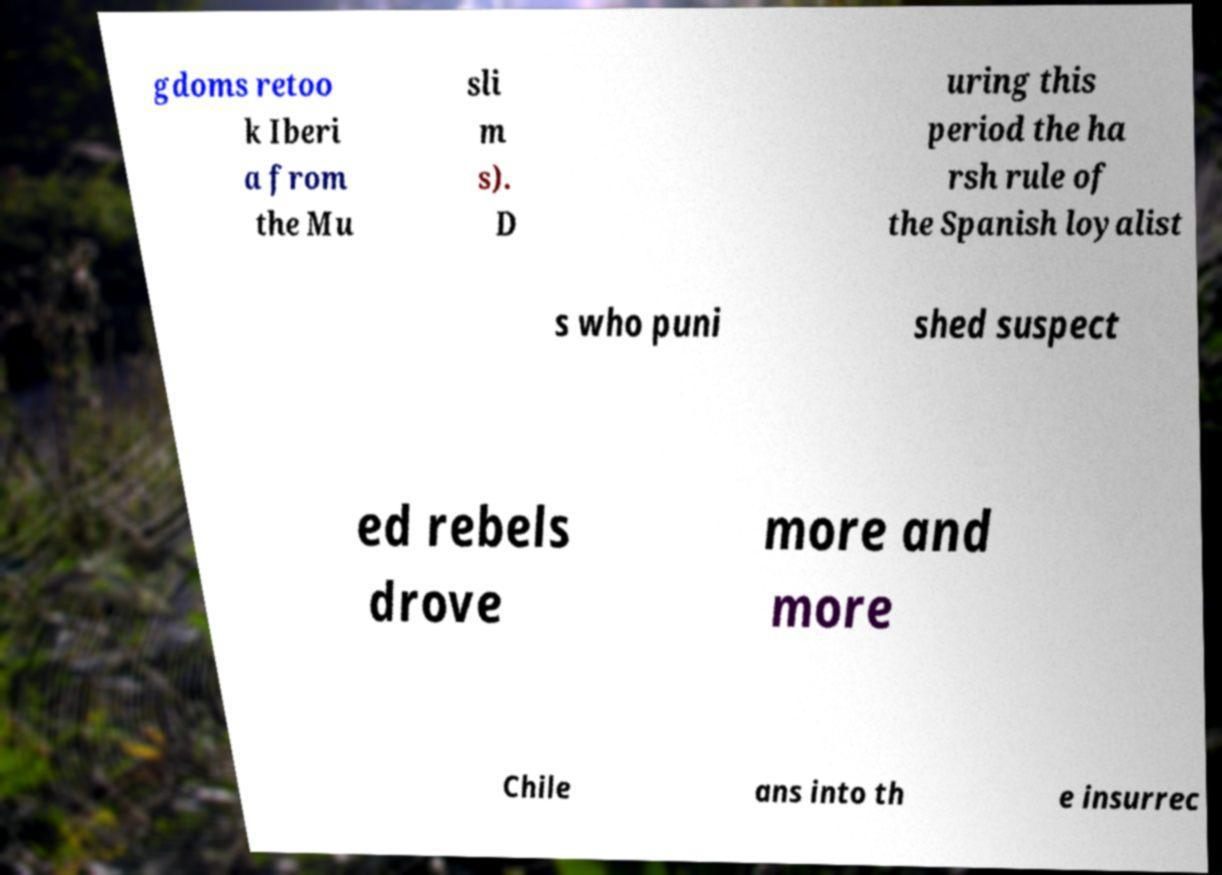Could you extract and type out the text from this image? gdoms retoo k Iberi a from the Mu sli m s). D uring this period the ha rsh rule of the Spanish loyalist s who puni shed suspect ed rebels drove more and more Chile ans into th e insurrec 